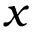Convert formula to latex. <formula><loc_0><loc_0><loc_500><loc_500>x</formula> 